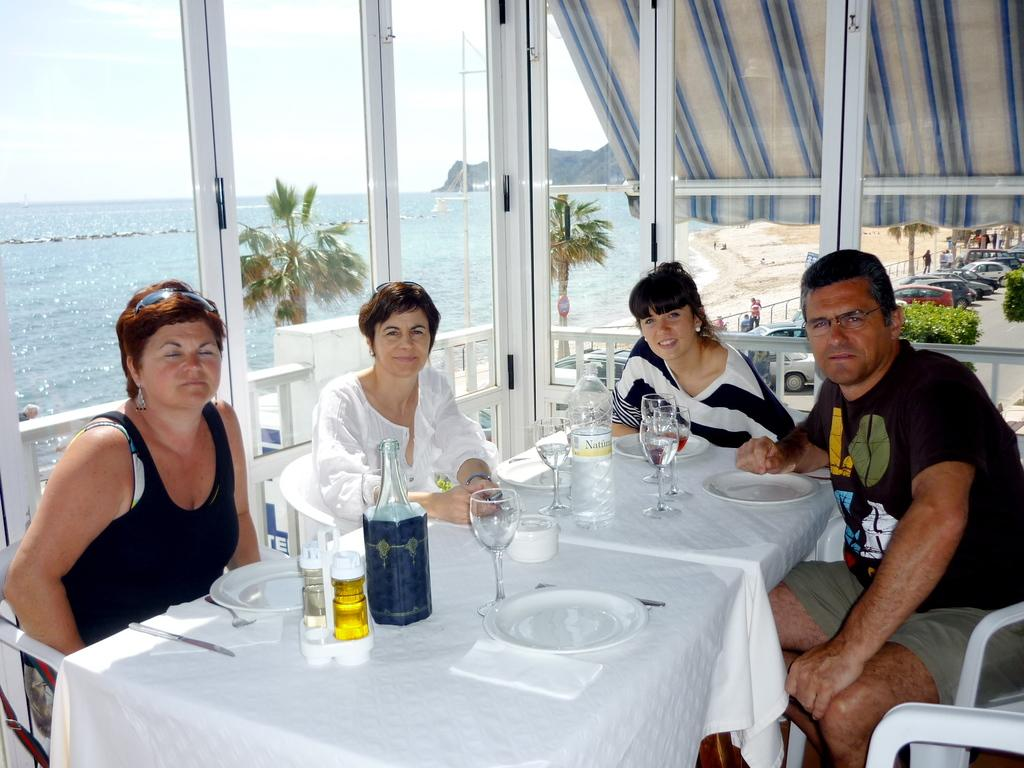What are the people in the image doing? There are persons sitting on chairs in the image. What natural feature can be seen in the image? There is a freshwater river in the image. What items are on the table in the image? There are bottles, glasses, and plates on a table in the image. What type of vegetation is present in the image? There are plants in the image. What can be seen in the distance in the image? There are vehicles visible on a road in the distance. How many grapes are being held by the babies in the image? There are no babies or grapes present in the image. What is the tendency of the plants in the image to grow towards the light? The provided facts do not mention the direction of growth for the plants in the image, so we cannot determine their tendency to grow towards the light. 